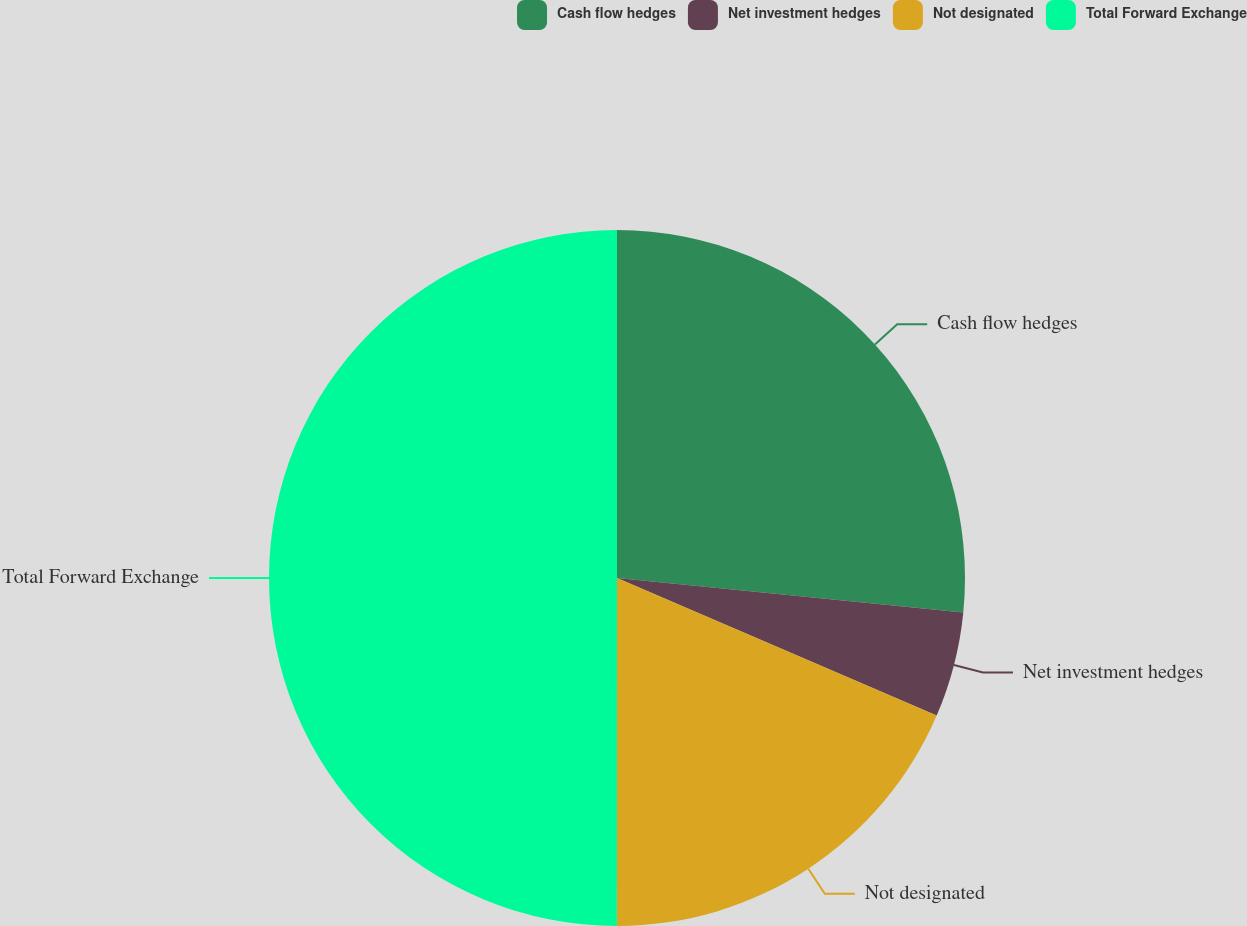Convert chart to OTSL. <chart><loc_0><loc_0><loc_500><loc_500><pie_chart><fcel>Cash flow hedges<fcel>Net investment hedges<fcel>Not designated<fcel>Total Forward Exchange<nl><fcel>26.58%<fcel>4.89%<fcel>18.54%<fcel>50.0%<nl></chart> 